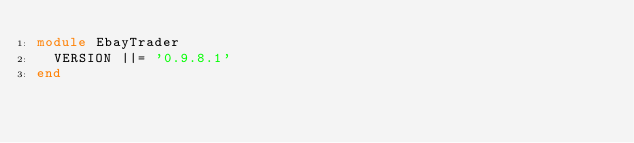Convert code to text. <code><loc_0><loc_0><loc_500><loc_500><_Ruby_>module EbayTrader
  VERSION ||= '0.9.8.1'
end
</code> 